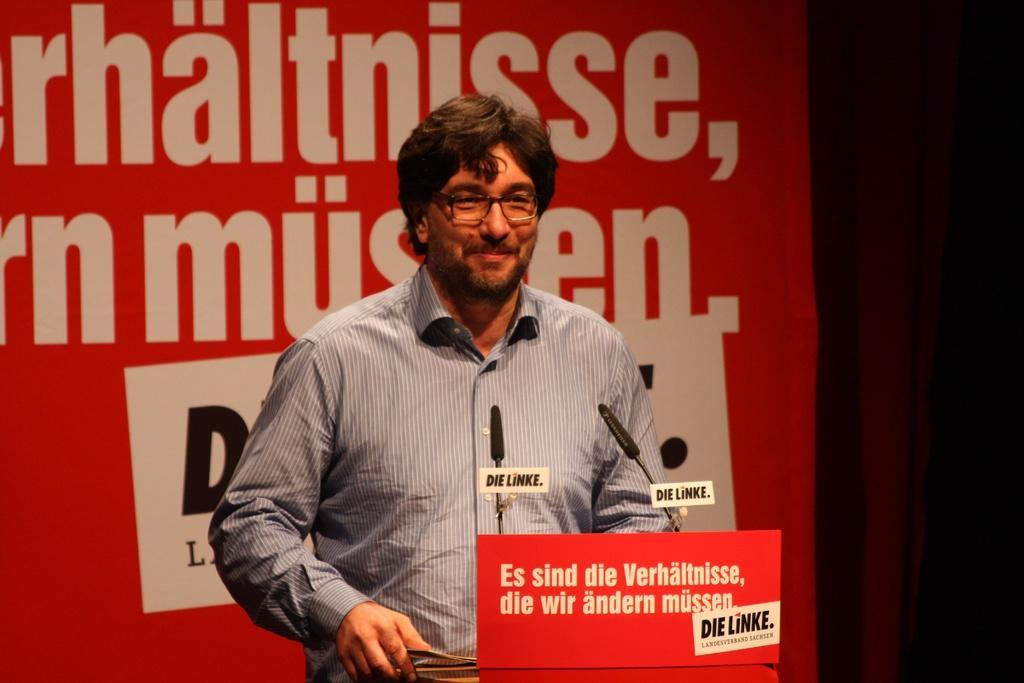Describe this image in one or two sentences. In this image we can see a person standing and there is a podium in front of him and we can see the mice and there is a board with some text on the podium. In the background, there is a banner with some text. 